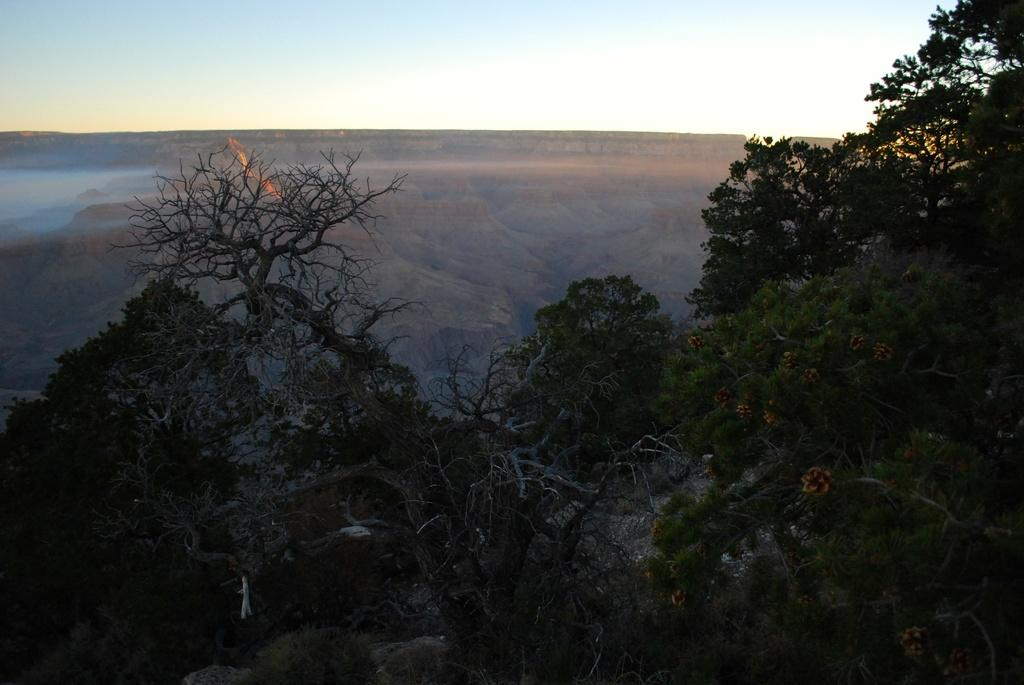What type of vegetation can be seen in the image? There are trees in the image. What geographical feature is located in the middle of the image? There is a hill in the middle of the image. What is visible at the top of the image? The sky is visible at the top of the image. What type of music can be heard coming from the trees in the image? There is no music present in the image, as it features trees and a hill with a visible sky. How many times does the person fall while climbing the hill in the image? There is no person present in the image, so it is not possible to determine how many times they might fall while climbing the hill. 